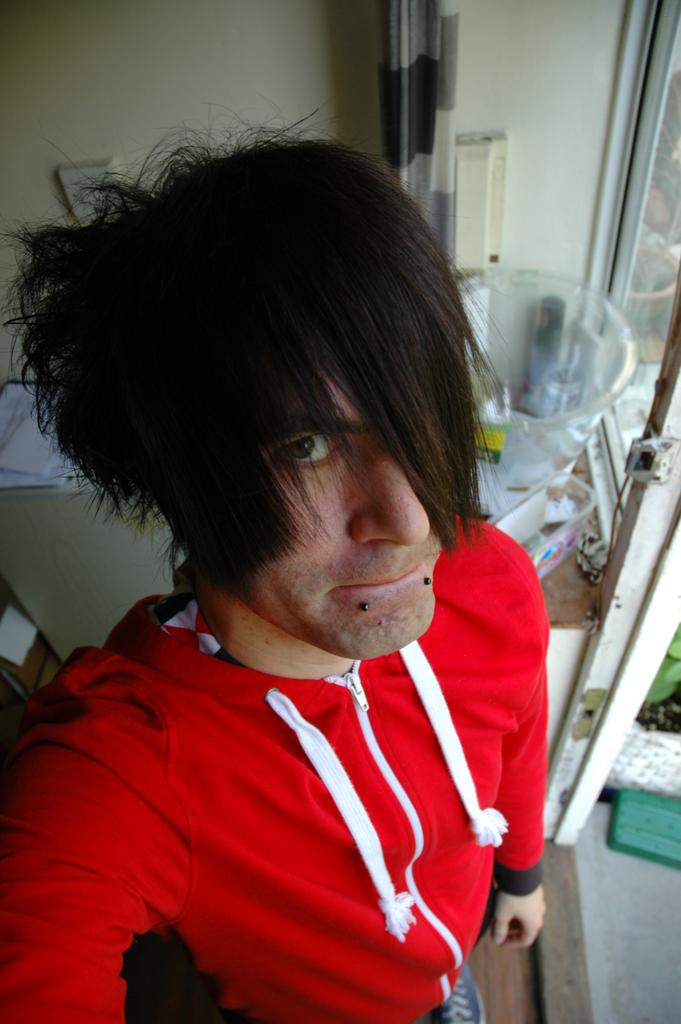What is the main subject of the image? There is a man in the image. What is the man wearing? The man is wearing a red jacket. What is the man doing in the image? The man is standing and taking a selfie. What can be seen in the background of the image? There is a wall and objects placed on a table in the background of the image. Can you see a stream in the background of the image? There is no stream visible in the background of the image. 